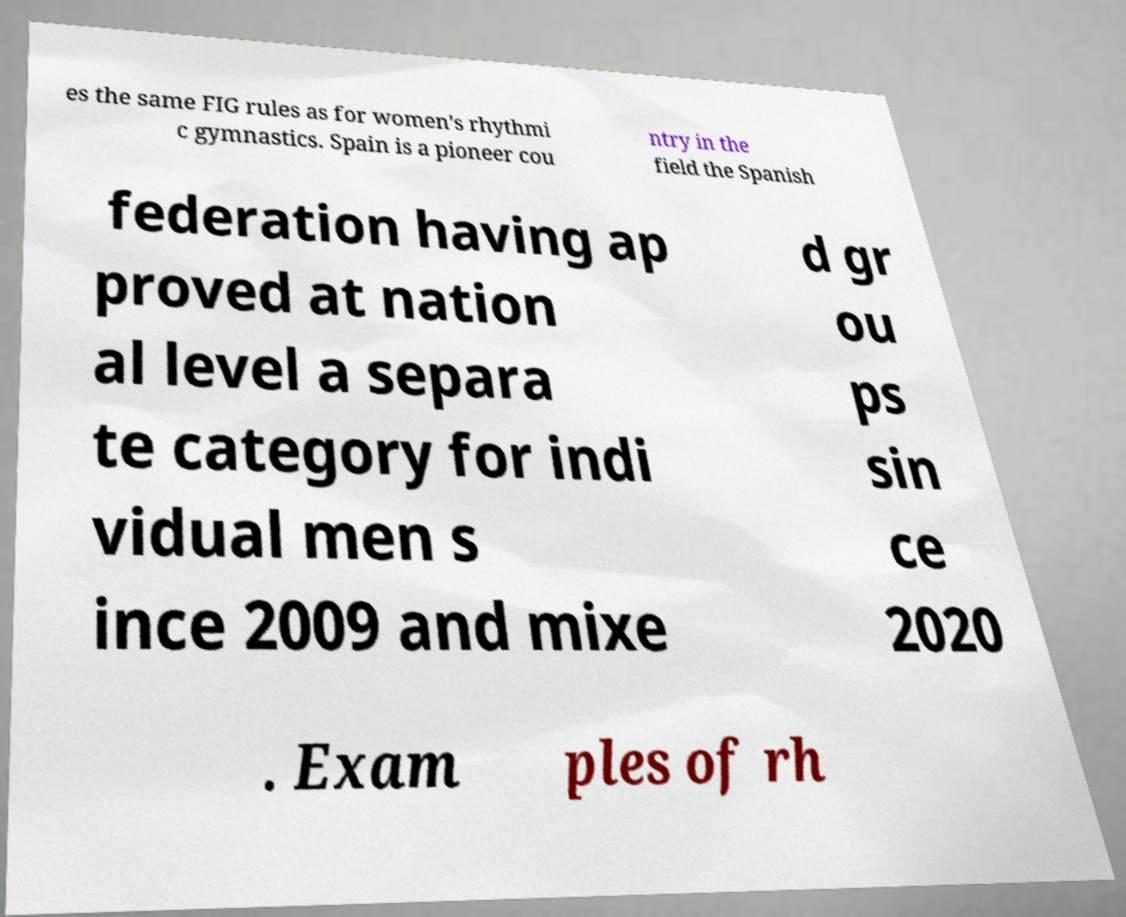Can you accurately transcribe the text from the provided image for me? es the same FIG rules as for women's rhythmi c gymnastics. Spain is a pioneer cou ntry in the field the Spanish federation having ap proved at nation al level a separa te category for indi vidual men s ince 2009 and mixe d gr ou ps sin ce 2020 . Exam ples of rh 